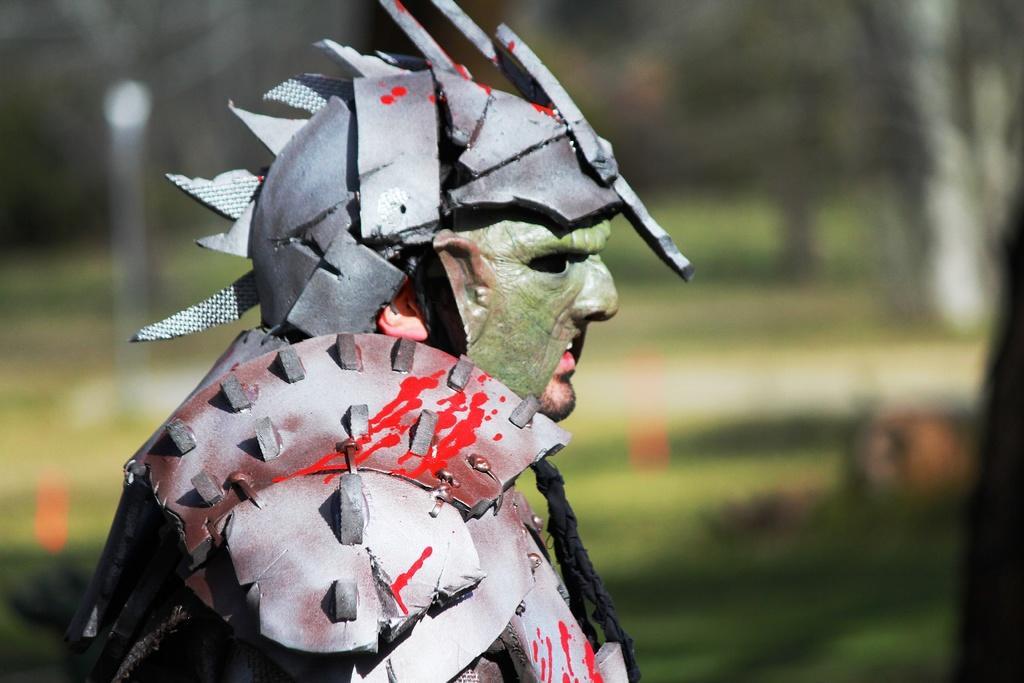In one or two sentences, can you explain what this image depicts? This picture is clicked outside. In the center we can see a person wearing some metal objects. The background of the image is blurry. 